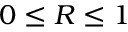Convert formula to latex. <formula><loc_0><loc_0><loc_500><loc_500>0 \leq R \leq 1</formula> 